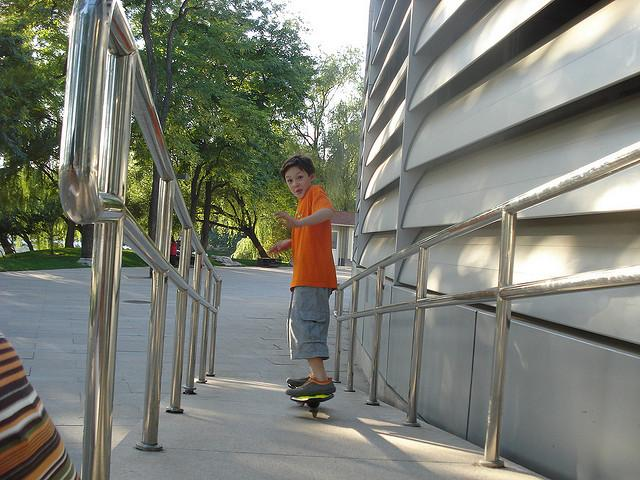What group of people is the ramp here constructed for?

Choices:
A) handicapped people
B) merchants
C) bikers
D) singers handicapped people 